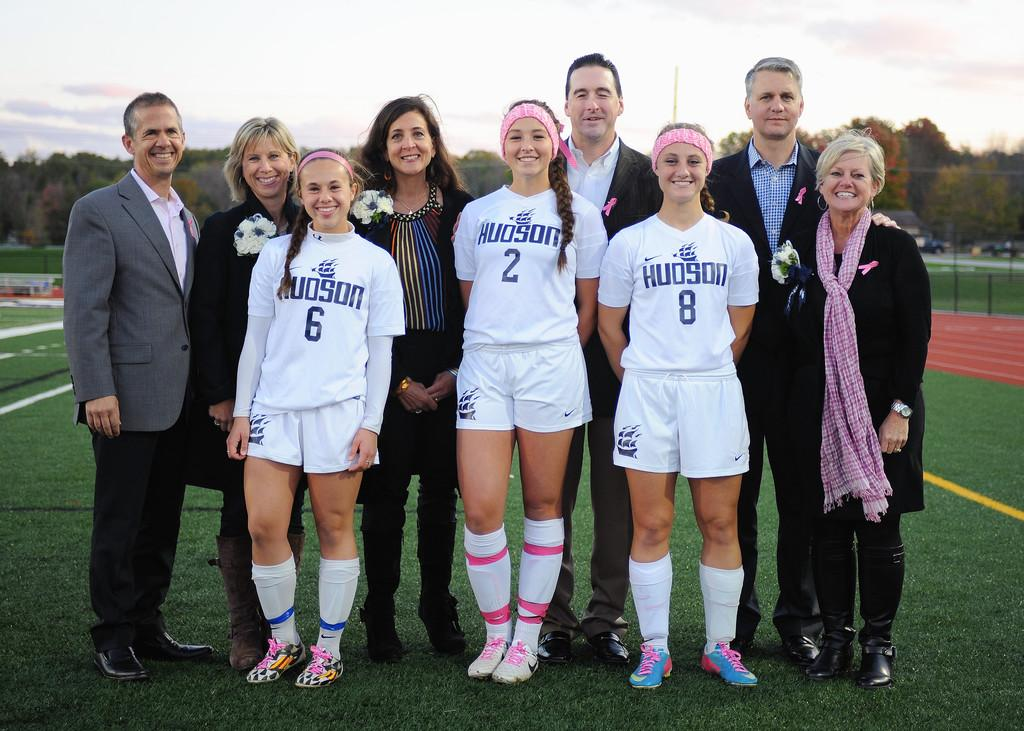<image>
Give a short and clear explanation of the subsequent image. The three girls wearing a sporting outfit wear the numbers 6, 2 and 8. 